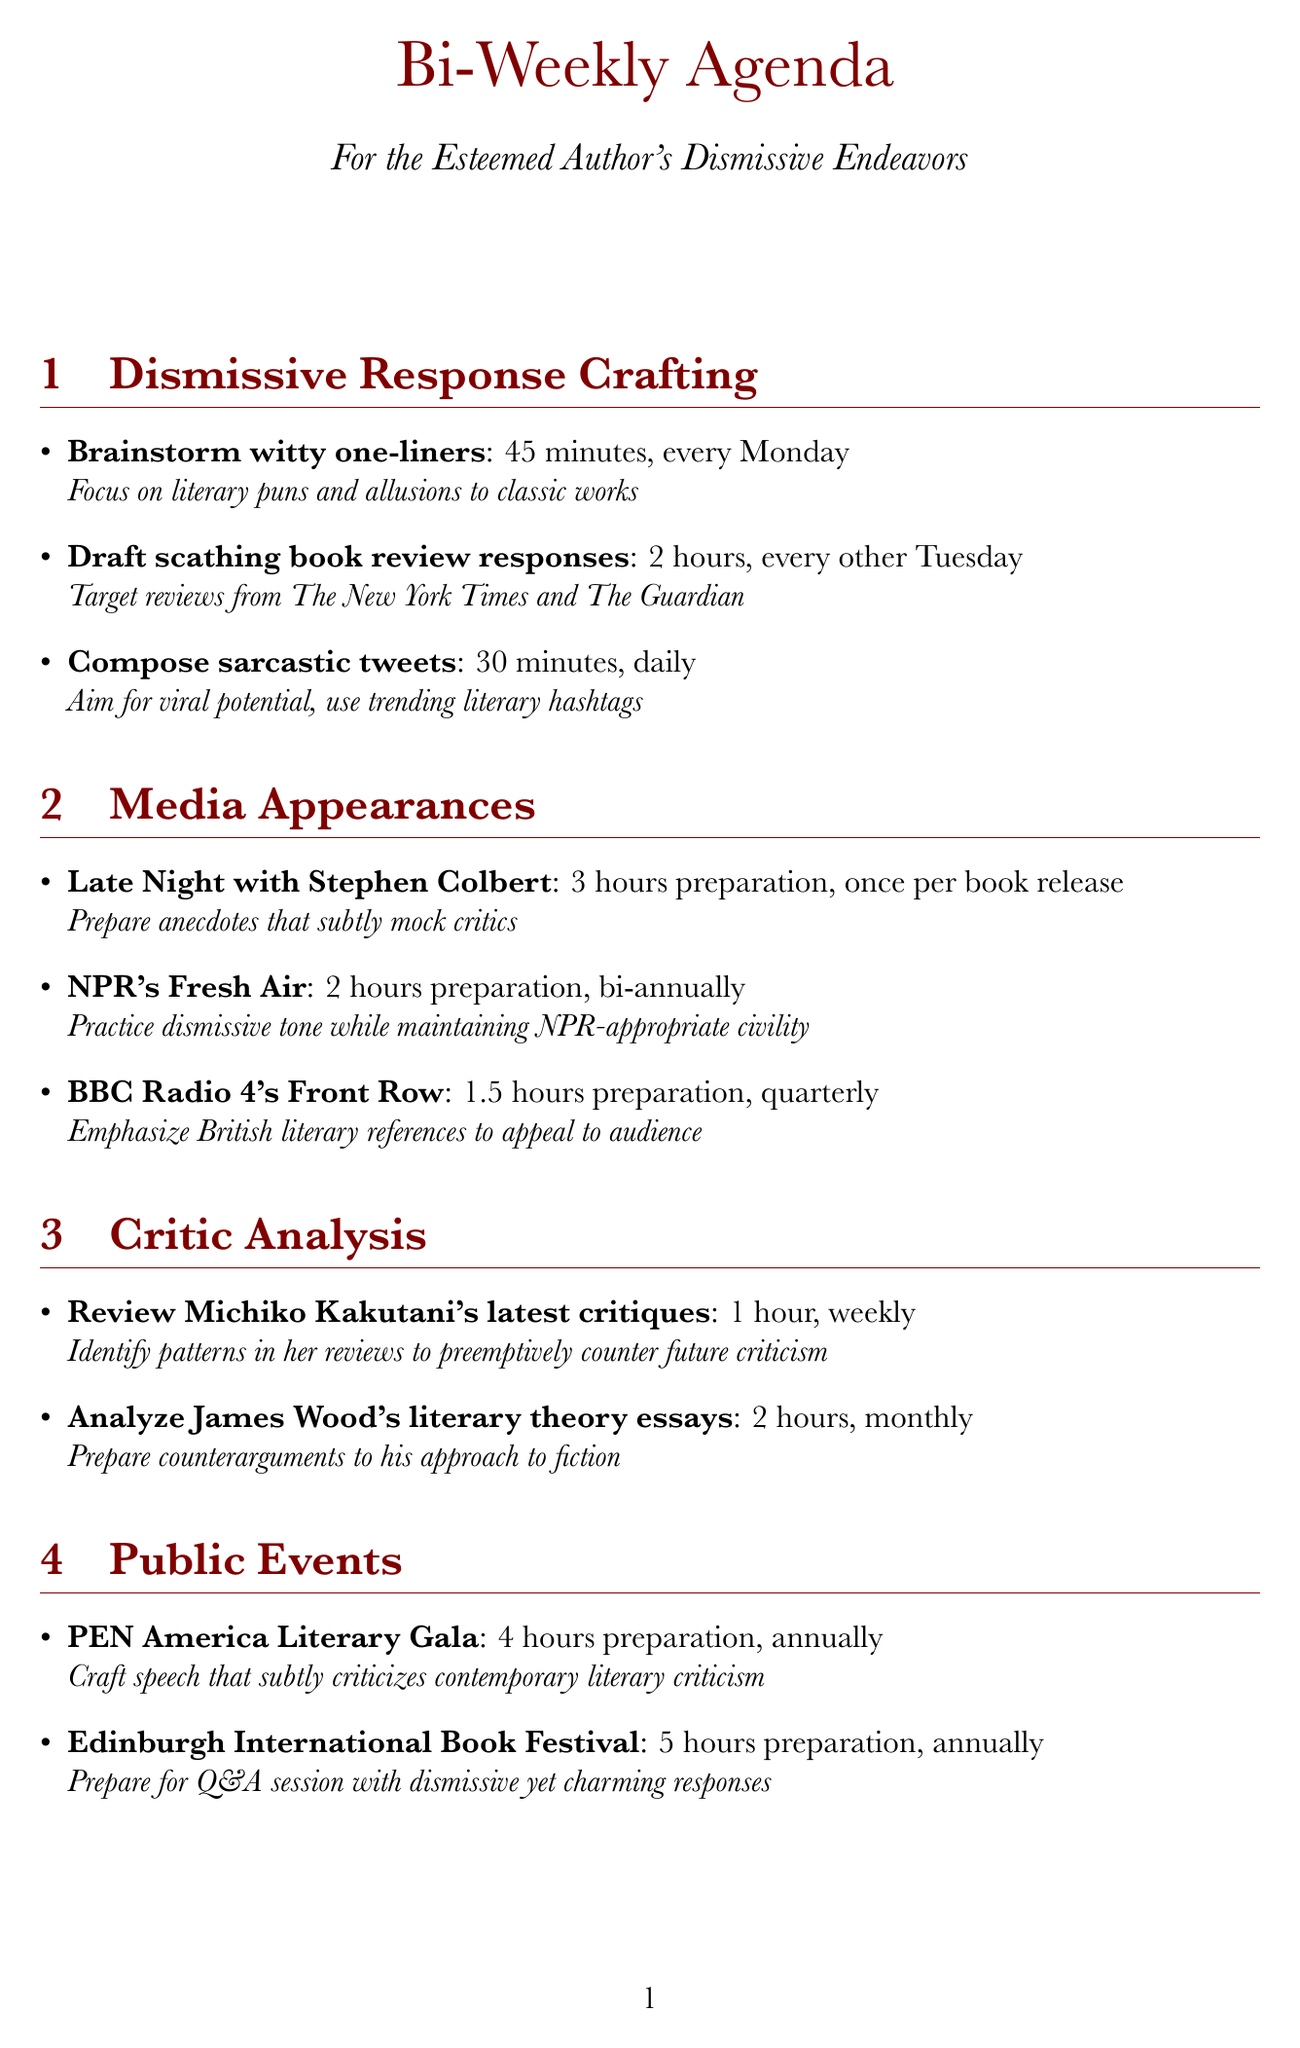What is the duration for drafting scathing book review responses? The document states that drafting scathing book review responses takes 2 hours.
Answer: 2 hours How often does the author compose sarcastic tweets? The document indicates that the author composes sarcastic tweets daily.
Answer: Daily What is the preparation time for NPR's Fresh Air? According to the document, the preparation time for NPR's Fresh Air is 2 hours.
Answer: 2 hours How many hours are allocated for writing a blog post responding to a recent negative review? The document specifies that writing a blog post takes 2 hours, as needed, typically bi-weekly.
Answer: 2 hours What event requires 4 hours of preparation? The document mentions that the PEN America Literary Gala requires 4 hours of preparation.
Answer: PEN America Literary Gala What is the frequency of reviewing Michiko Kakutani's latest critiques? The document states that reviewing Michiko Kakutani's critiques is done weekly.
Answer: Weekly What literary festival is scheduled annually? The document indicates that the Edinburgh International Book Festival is scheduled annually.
Answer: Edinburgh International Book Festival How long is the preparation time for appearances on BBC Radio 4's Front Row? The document specifies that the preparation time for BBC Radio 4's Front Row is 1.5 hours.
Answer: 1.5 hours What is the primary focus for brainstorming witty one-liners? The document notes that the focus should be on literary puns and allusions to classic works.
Answer: Literary puns and allusions to classic works 